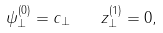Convert formula to latex. <formula><loc_0><loc_0><loc_500><loc_500>\psi ^ { ( 0 ) } _ { \bot } = c _ { \bot } \quad z _ { \bot } ^ { ( 1 ) } = 0 ,</formula> 